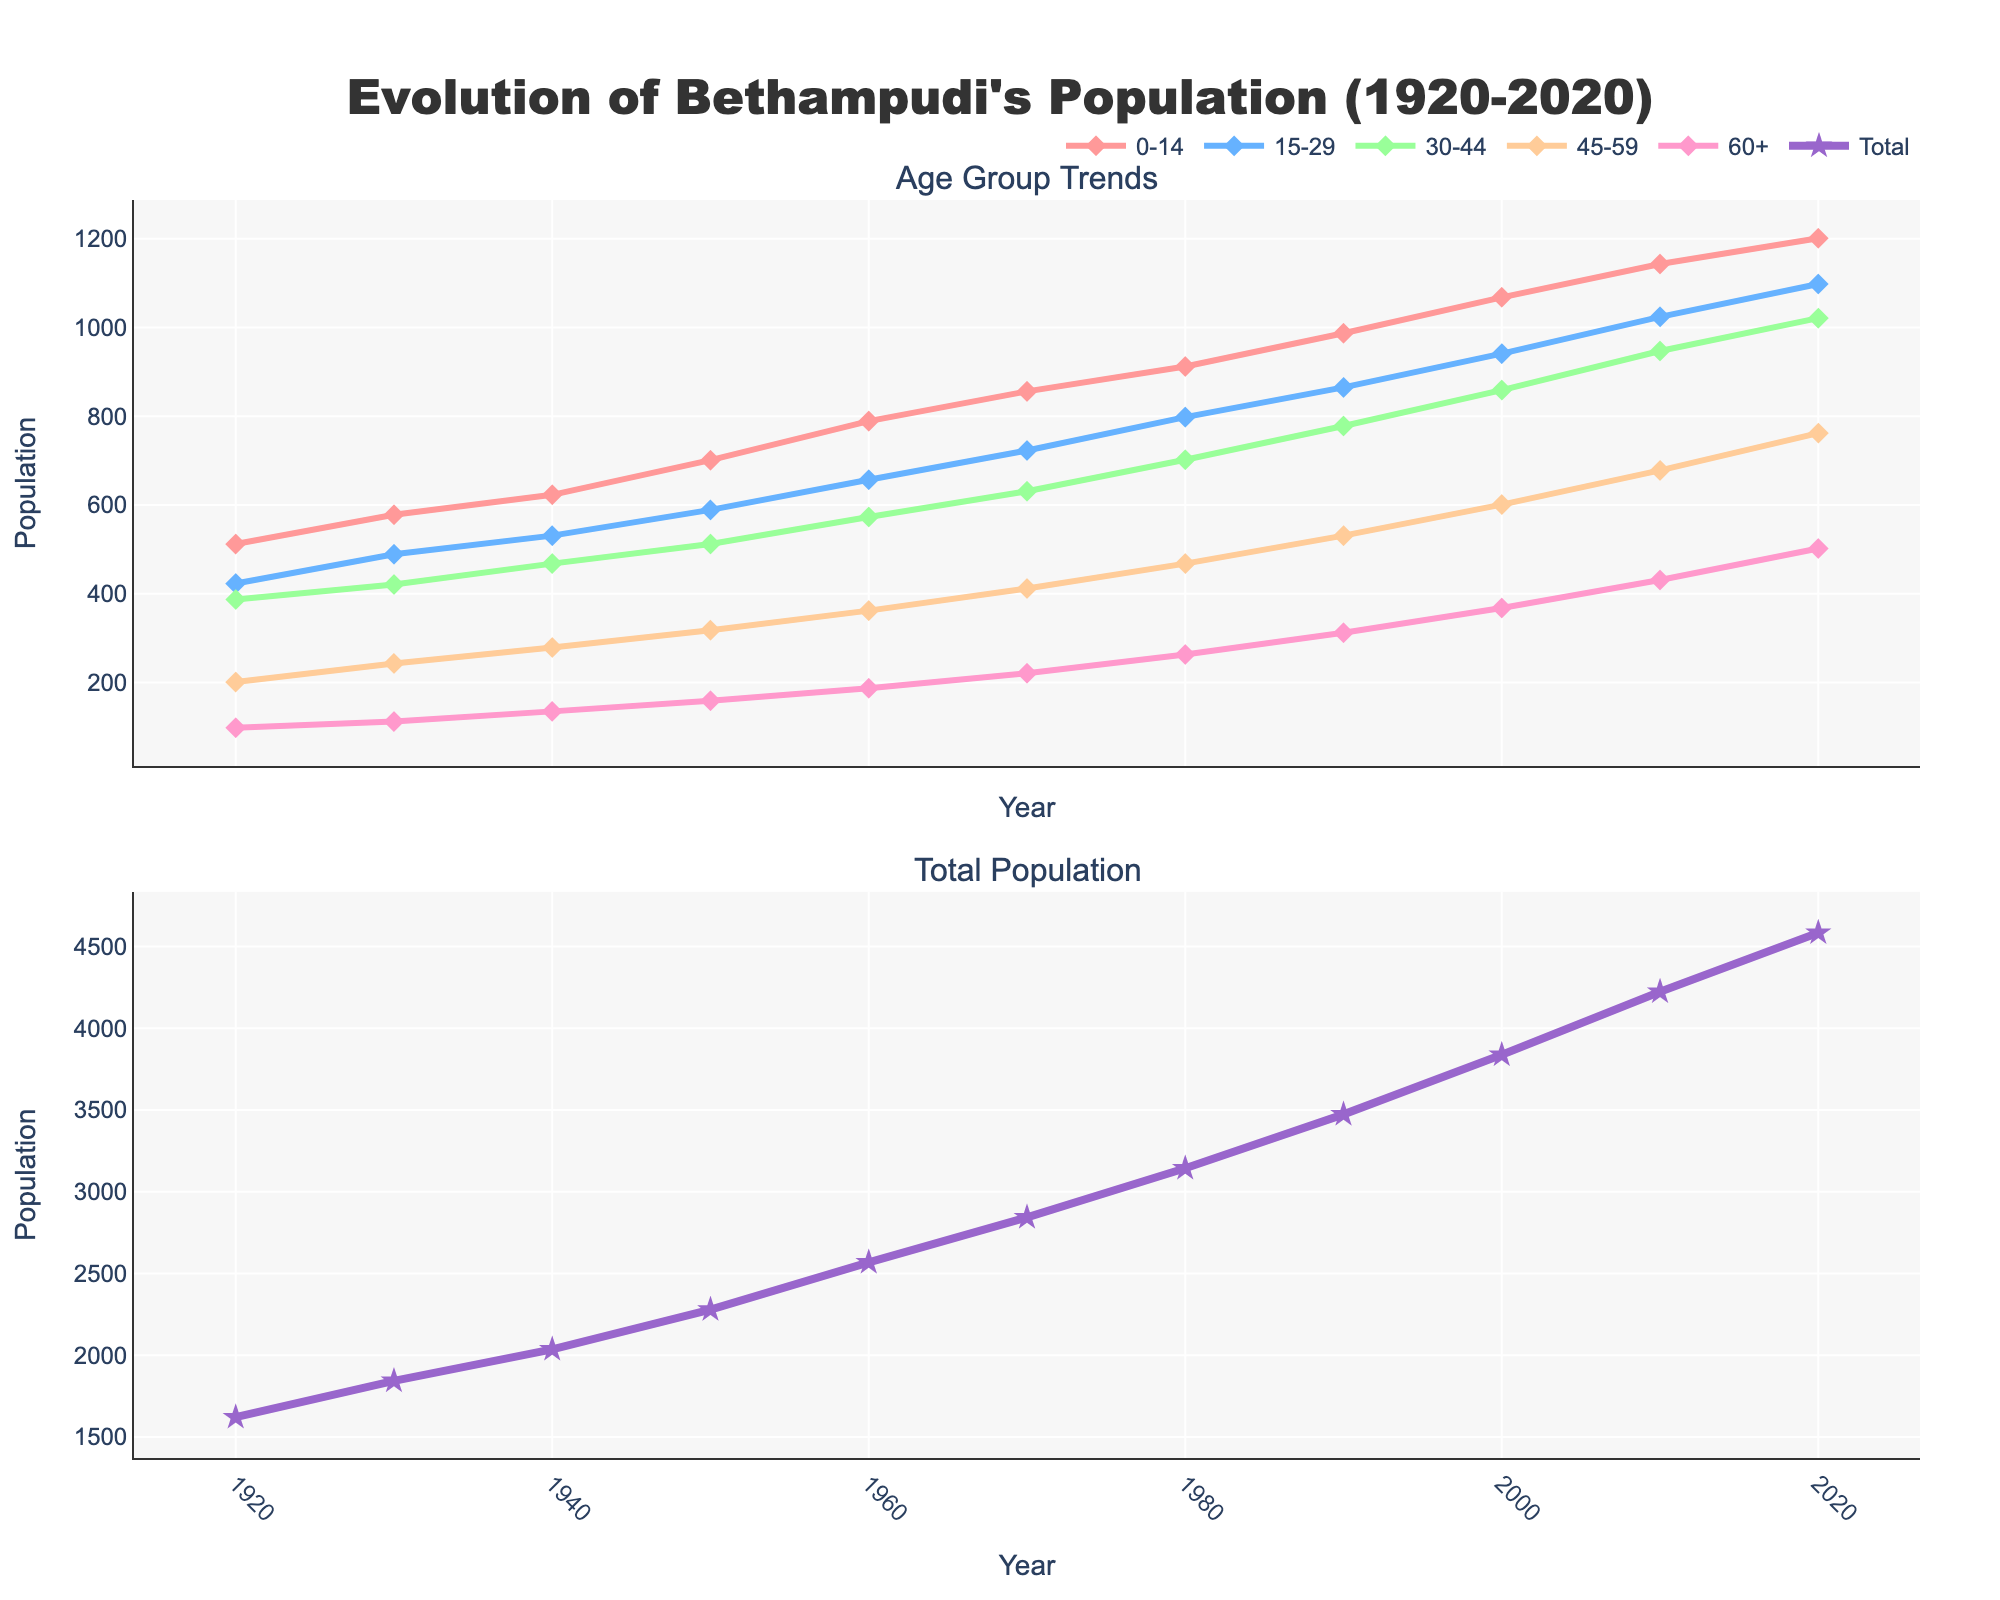what is the growth rate of the total population between 1920 and 2020? To find the growth rate, subtract the population in 1920 from the population in 2020, and then divide by the population in 1920. Multiply the result by 100 to get the percentage. The population in 1920 was 1621, and in 2020 it was 4584. So, (4584-1621)/1621 * 100 ≈ 182.84%
Answer: 182.84% Which age group had the highest population increase between 2000 and 2020? To find this, compare the population of each age group in 2000 and 2020. For the 0-14 group: 1201-1068 = 133; 15-29 group: 1098-941 = 157; 30-44 group: 1021-859 = 162; 45-59 group: 762-601 = 161; 60+ group: 502-368 = 134. The highest increase is in the 30-44 age group with an increase of 162.
Answer: 30-44 How did the population of the 45-59 age group change from 1950 to 1980? Examine the population of the 45-59 age group in 1950 and 1980. In 1950, the population was 318, and in 1980, it was 468. The change is 468 - 318 = 150, indicating an increase of 150.
Answer: 150 Which age group had the smallest population in 1940, and what was that population? Look at the data for each age group in 1940. The 60+ age group had the smallest population at 135.
Answer: 60+, 135 Compare the trends of the 0-14 and 60+ age groups from 1920 to 2020. Which group showed a more significant increase? Observe the population trends of both age groups from 1920 to 2020. The 0-14 age group increased from 512 to 1201, while the 60+ group increased from 98 to 502. The increase for 0-14 is 1201 - 512 = 689 and for 60+ is 502 - 98 = 404. The 0-14 age group showed a more significant increase.
Answer: 0-14 What is the average population of the 15-29 age group over the entire period? To find the average, sum the population of the 15-29 age group for each decade and divide by the number of decades. (423 + 489 + 531 + 589 + 657 + 723 + 798 + 865 + 941 + 1024 + 1098) / 11 = 714.
Answer: 714 In which decade did the total population of Bethampudi exceed 3000 for the first time? Inspect the total population data to find the first instance where it exceeds 3000. The total population exceeded 3000 for the first time in the 1980s with 3143.
Answer: 1980s What is the difference in population between the 30-44 and 45-59 age groups in 2020? Subtract the population of the 45-59 age group from the 30-44 age group in 2020. 1021 - 762 = 259.
Answer: 259 What visual trends can be observed for the 0-14 age group from the first subplot? Look at the line representing the 0-14 age group in the plot. The trend shows a consistent increase from 1920 to 2020.
Answer: Consistent increase 